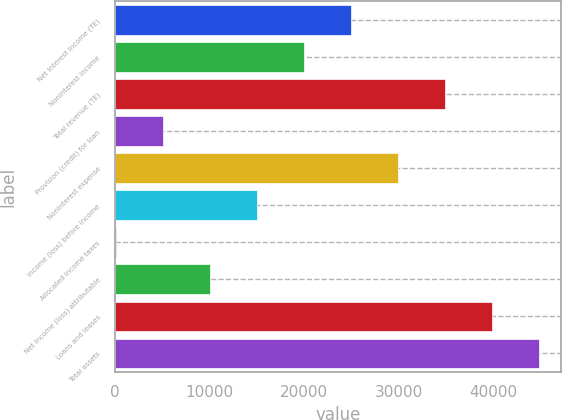<chart> <loc_0><loc_0><loc_500><loc_500><bar_chart><fcel>Net interest income (TE)<fcel>Noninterest income<fcel>Total revenue (TE)<fcel>Provision (credit) for loan<fcel>Noninterest expense<fcel>Income (loss) before income<fcel>Allocated income taxes<fcel>Net income (loss) attributable<fcel>Loans and leases<fcel>Total assets<nl><fcel>24962.5<fcel>19994.2<fcel>34899.1<fcel>5089.3<fcel>29930.8<fcel>15025.9<fcel>121<fcel>10057.6<fcel>39867.4<fcel>44835.7<nl></chart> 